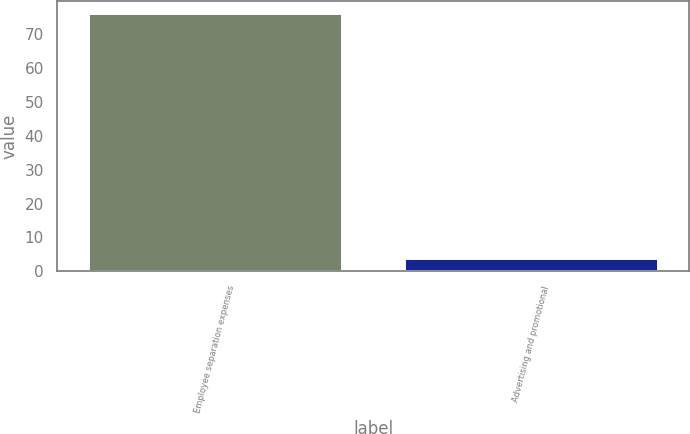Convert chart. <chart><loc_0><loc_0><loc_500><loc_500><bar_chart><fcel>Employee separation expenses<fcel>Advertising and promotional<nl><fcel>75.9<fcel>3.7<nl></chart> 